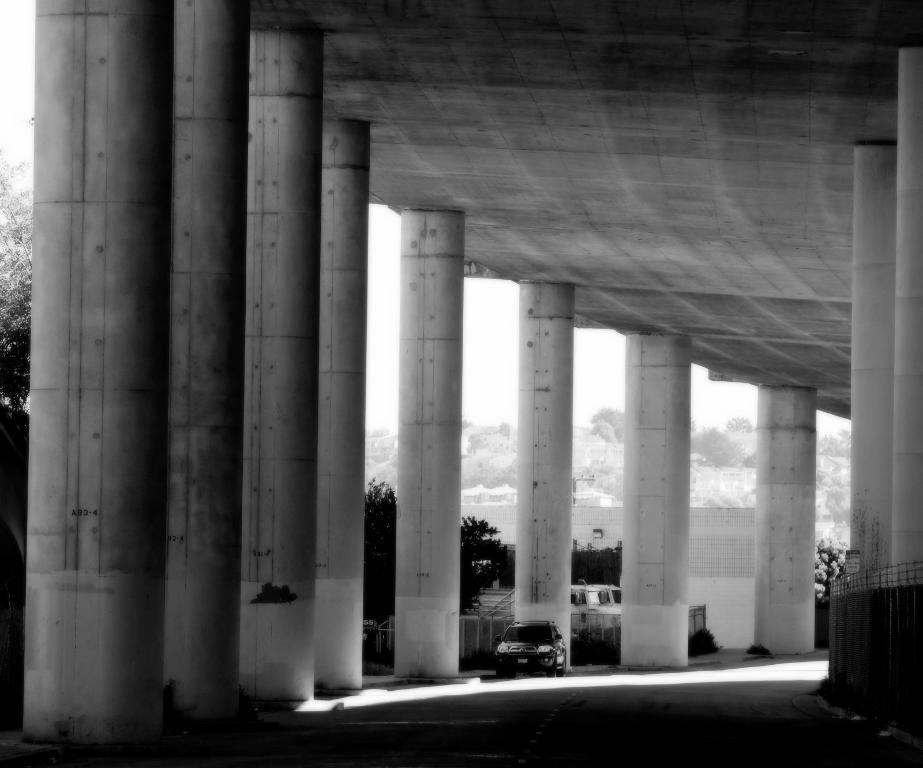What is on the road in the image? There is a vehicle on the road in the image. What type of structures can be seen in the image? There are roofs, pillars, and fences visible in the image. What type of vegetation is present in the image? There are trees in the image. What else can be seen in the image besides the mentioned objects? There are some objects in the image. What is visible in the background of the image? The sky is visible in the background of the image. How does the anger manifest itself in the image? There is no indication of anger in the image; it is a neutral representation of the scene. 